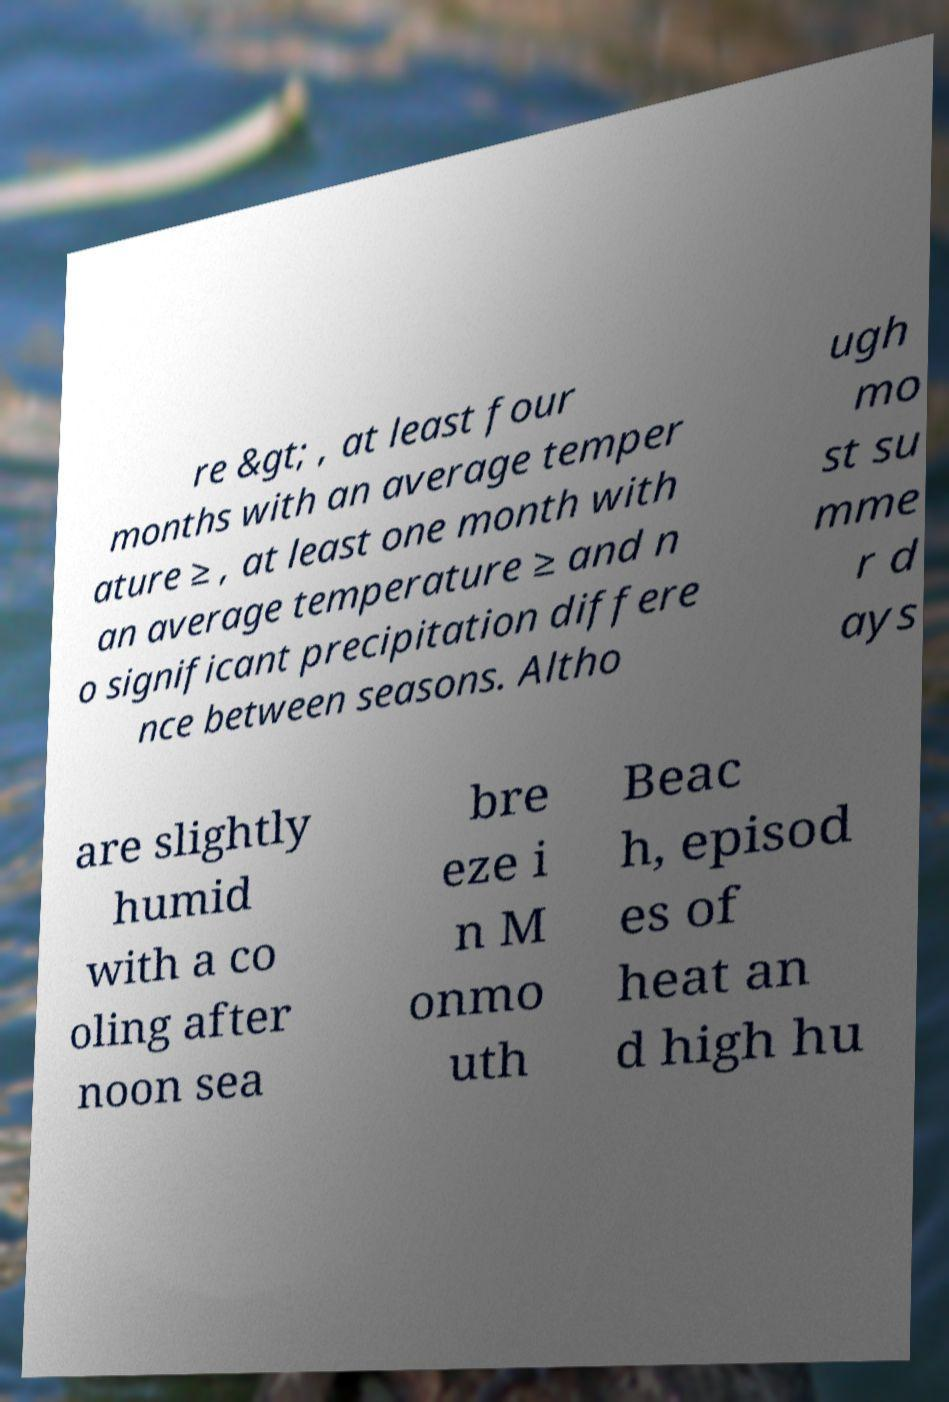Can you read and provide the text displayed in the image?This photo seems to have some interesting text. Can you extract and type it out for me? re &gt; , at least four months with an average temper ature ≥ , at least one month with an average temperature ≥ and n o significant precipitation differe nce between seasons. Altho ugh mo st su mme r d ays are slightly humid with a co oling after noon sea bre eze i n M onmo uth Beac h, episod es of heat an d high hu 